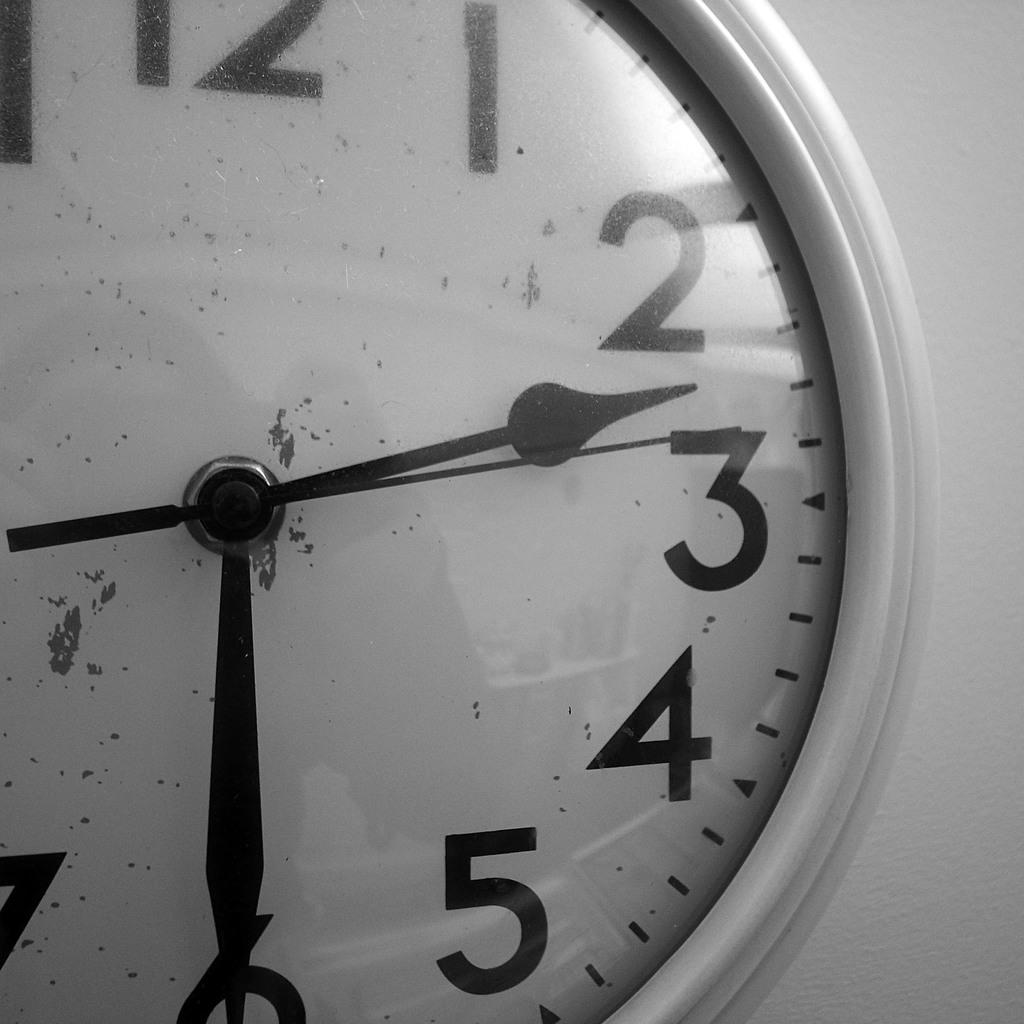<image>
Create a compact narrative representing the image presented. A dirty wall clock shows the time as 2:30. 